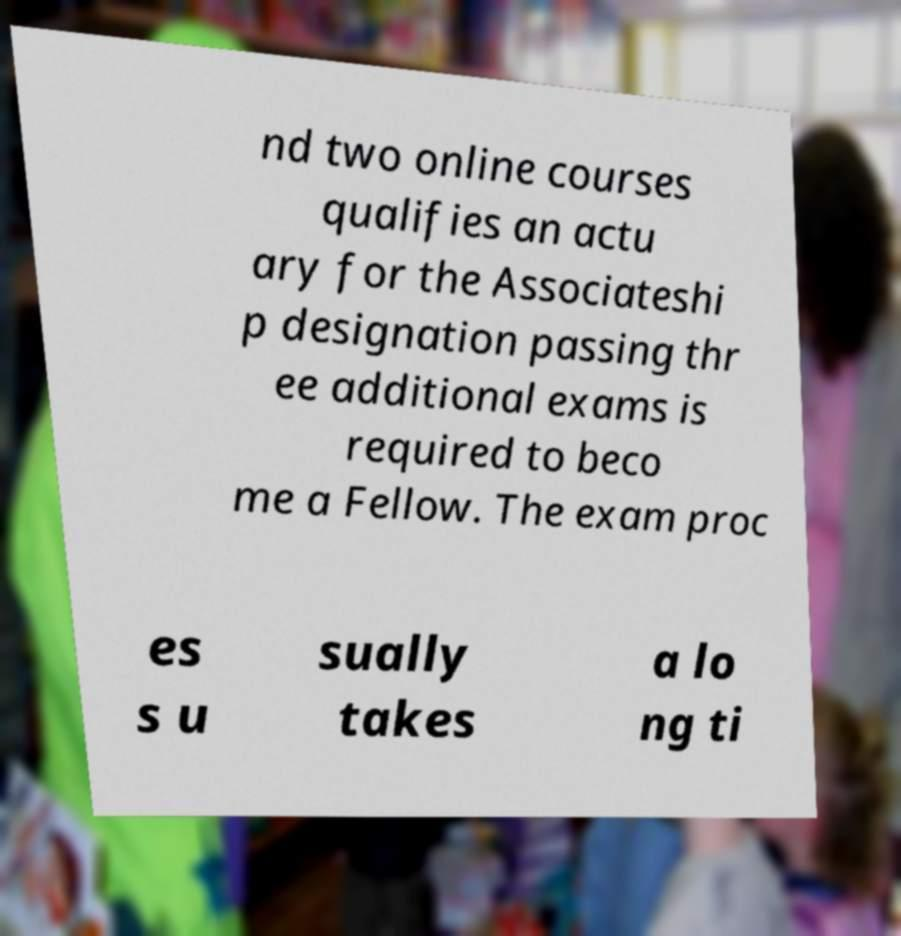Could you assist in decoding the text presented in this image and type it out clearly? nd two online courses qualifies an actu ary for the Associateshi p designation passing thr ee additional exams is required to beco me a Fellow. The exam proc es s u sually takes a lo ng ti 